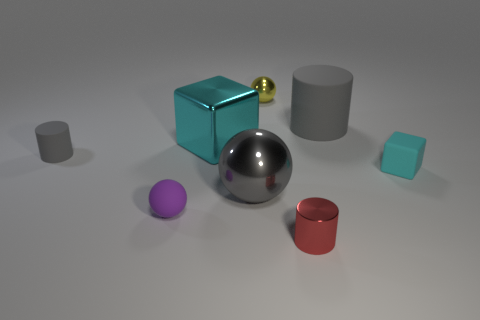Subtract all metal cylinders. How many cylinders are left? 2 Add 1 small green shiny things. How many objects exist? 9 Subtract all red cylinders. How many cylinders are left? 2 Subtract all cylinders. How many objects are left? 5 Subtract 2 cylinders. How many cylinders are left? 1 Subtract 0 blue cubes. How many objects are left? 8 Subtract all cyan cylinders. Subtract all yellow blocks. How many cylinders are left? 3 Subtract all red cylinders. How many yellow balls are left? 1 Subtract all purple rubber balls. Subtract all tiny cyan rubber cubes. How many objects are left? 6 Add 2 cyan matte things. How many cyan matte things are left? 3 